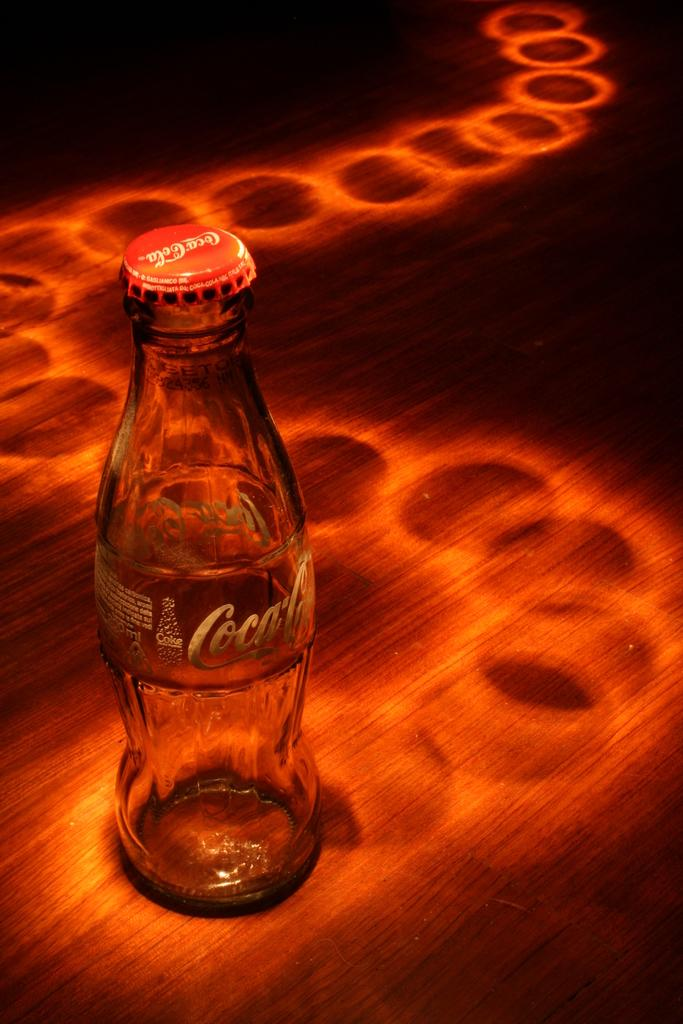What is the main object in the center of the image? There is a coke bottle in the center of the image. What type of brain activity can be observed in the image? There is no brain present in the image, so it is not possible to observe any brain activity. 